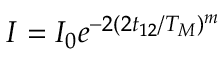<formula> <loc_0><loc_0><loc_500><loc_500>I = I _ { 0 } e ^ { - 2 ( 2 t _ { 1 2 } / T _ { M } ) ^ { m } }</formula> 